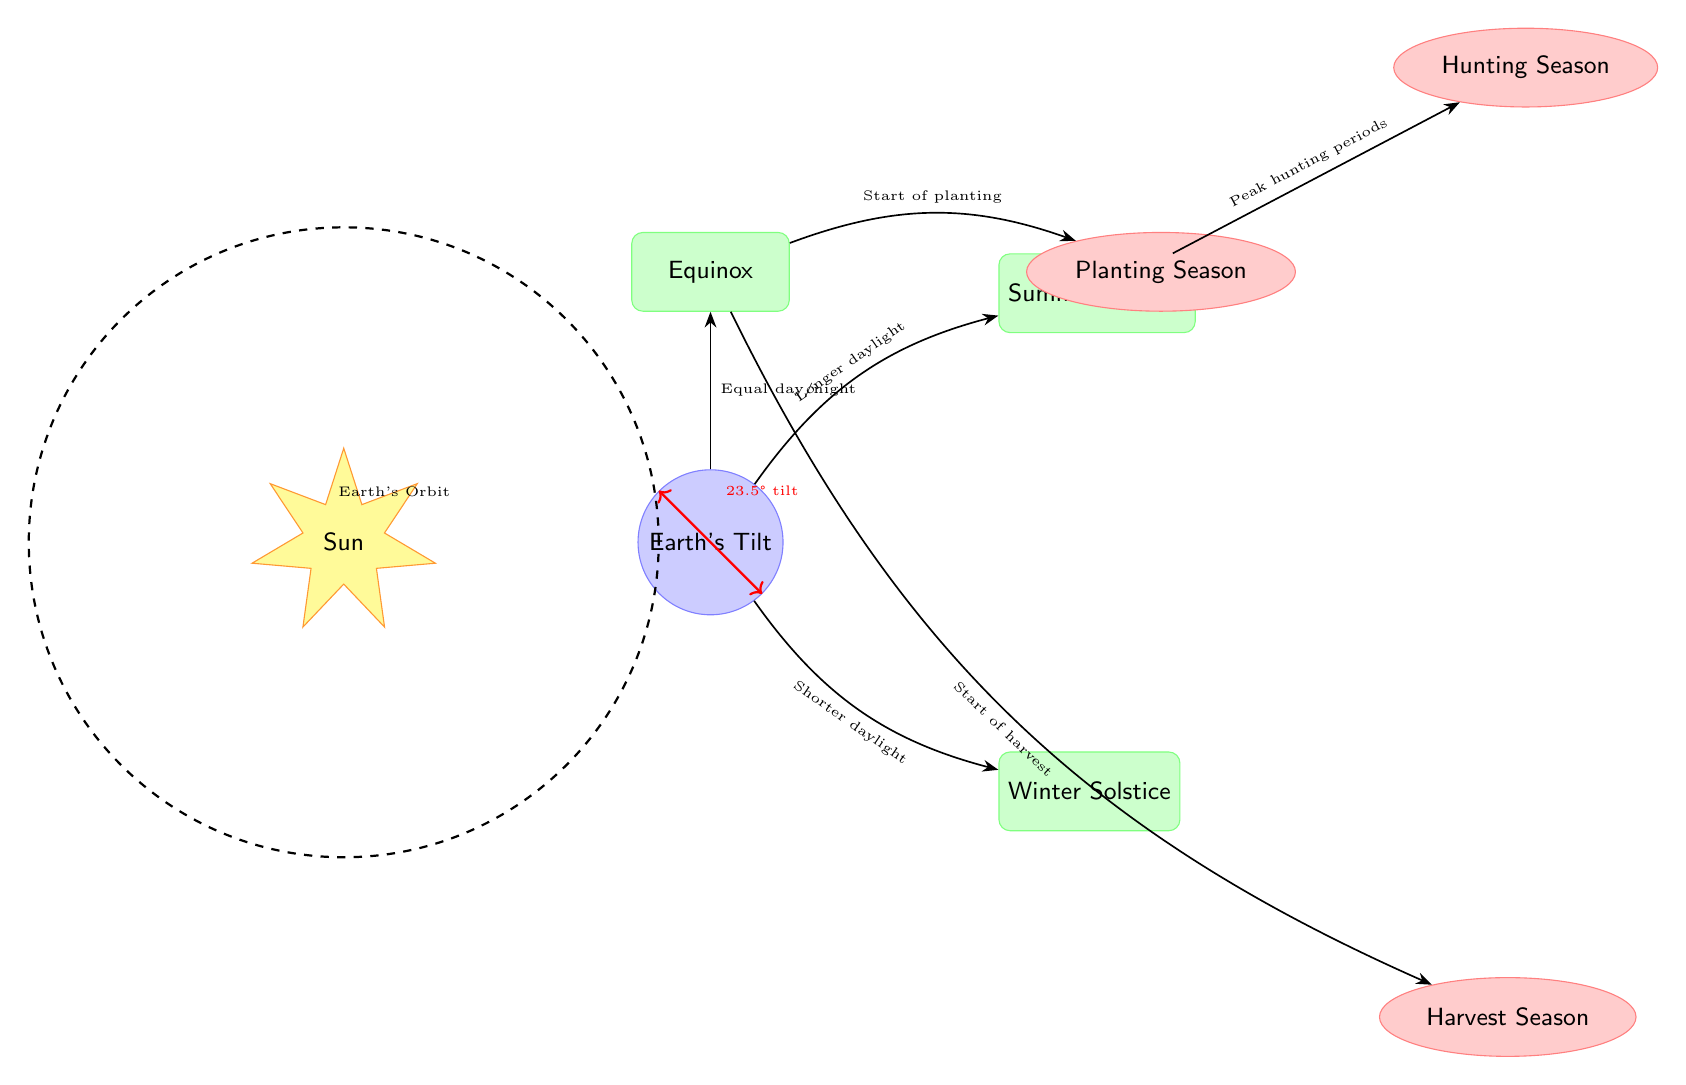What is the tilt of the Earth? The diagram indicates that the Earth's tilt is 23.5°, which is directly marked next to the Earth node with a red annotation.
Answer: 23.5° What are the seasonal changes illustrated in the diagram? The diagram shows three seasonal changes: Summer Solstice, Winter Solstice, and Equinox, represented in individual nodes connected to the Earth node.
Answer: Summer Solstice, Winter Solstice, Equinox Which season is associated with longer daylight? The arrow indicates that from the Earth node to the Summer Solstice node, it states "Longer daylight," revealing that the Summer Solstice is associated with longer daylight.
Answer: Summer Solstice What activity is linked to the Winter Solstice? The diagram shows an arrow pointing downward from the Winter Solstice, indicating a connection to the "Harvest Season," which is the activity linked to this solstice.
Answer: Harvest Season How does the Equinox relate to planting? The diagram features an arrow from the Equinox node to the Planting Season node, labeled "Start of planting," indicating that the Equinox marks the beginning of the planting activity.
Answer: Start of planting During which solstice is the hunting season peak? By looking at the arrow that flows from the Summer Solstice to the Hunting Season, labeled "Peak hunting periods," it's clear that the peak hunting season occurs during the Summer Solstice.
Answer: Summer Solstice What does the dashed circle represent in the diagram? The dashed circle around the Sun node is explicitly labeled “Earth's Orbit” in a note, indicating that this circular line represents the path of Earth around the Sun.
Answer: Earth's Orbit How does the length of daylight change from the Winter Solstice to the Summer Solstice? The diagram shows that the Winter Solstice is associated with "Shorter daylight," while the Summer Solstice is indicated as "Longer daylight," demonstrating that the length of daylight increases from winter to summer solstice.
Answer: Increases What seasonal change is directly above the Earth node? The diagram positions the Equinox node directly above the Earth node, which means that it is the seasonal change directly associated with this position relative to the Earth.
Answer: Equinox 